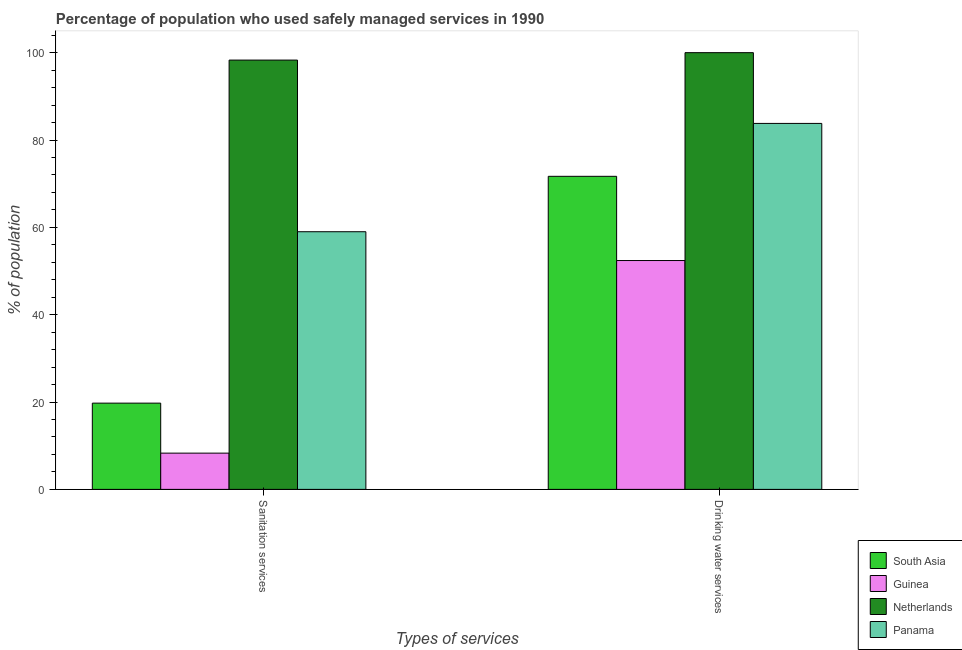How many different coloured bars are there?
Give a very brief answer. 4. How many groups of bars are there?
Your response must be concise. 2. Are the number of bars per tick equal to the number of legend labels?
Your response must be concise. Yes. Are the number of bars on each tick of the X-axis equal?
Your response must be concise. Yes. What is the label of the 2nd group of bars from the left?
Your response must be concise. Drinking water services. What is the percentage of population who used sanitation services in Netherlands?
Give a very brief answer. 98.3. Across all countries, what is the maximum percentage of population who used sanitation services?
Your answer should be compact. 98.3. Across all countries, what is the minimum percentage of population who used drinking water services?
Make the answer very short. 52.4. In which country was the percentage of population who used sanitation services maximum?
Your answer should be compact. Netherlands. In which country was the percentage of population who used sanitation services minimum?
Make the answer very short. Guinea. What is the total percentage of population who used drinking water services in the graph?
Provide a succinct answer. 307.89. What is the difference between the percentage of population who used sanitation services in South Asia and that in Guinea?
Your answer should be compact. 11.45. What is the difference between the percentage of population who used drinking water services in Guinea and the percentage of population who used sanitation services in Panama?
Your answer should be very brief. -6.6. What is the average percentage of population who used sanitation services per country?
Provide a succinct answer. 46.34. What is the difference between the percentage of population who used sanitation services and percentage of population who used drinking water services in Panama?
Provide a succinct answer. -24.8. In how many countries, is the percentage of population who used drinking water services greater than 80 %?
Offer a very short reply. 2. What is the ratio of the percentage of population who used drinking water services in Guinea to that in South Asia?
Offer a terse response. 0.73. What does the 4th bar from the left in Sanitation services represents?
Your answer should be very brief. Panama. What does the 3rd bar from the right in Drinking water services represents?
Provide a short and direct response. Guinea. Are all the bars in the graph horizontal?
Make the answer very short. No. How many countries are there in the graph?
Provide a short and direct response. 4. Are the values on the major ticks of Y-axis written in scientific E-notation?
Provide a succinct answer. No. Where does the legend appear in the graph?
Ensure brevity in your answer.  Bottom right. How are the legend labels stacked?
Your answer should be compact. Vertical. What is the title of the graph?
Offer a terse response. Percentage of population who used safely managed services in 1990. What is the label or title of the X-axis?
Provide a succinct answer. Types of services. What is the label or title of the Y-axis?
Provide a short and direct response. % of population. What is the % of population of South Asia in Sanitation services?
Your answer should be very brief. 19.75. What is the % of population in Netherlands in Sanitation services?
Provide a short and direct response. 98.3. What is the % of population of Panama in Sanitation services?
Offer a terse response. 59. What is the % of population of South Asia in Drinking water services?
Provide a succinct answer. 71.69. What is the % of population of Guinea in Drinking water services?
Give a very brief answer. 52.4. What is the % of population of Netherlands in Drinking water services?
Provide a succinct answer. 100. What is the % of population in Panama in Drinking water services?
Provide a succinct answer. 83.8. Across all Types of services, what is the maximum % of population in South Asia?
Provide a succinct answer. 71.69. Across all Types of services, what is the maximum % of population of Guinea?
Offer a very short reply. 52.4. Across all Types of services, what is the maximum % of population of Netherlands?
Offer a terse response. 100. Across all Types of services, what is the maximum % of population of Panama?
Offer a terse response. 83.8. Across all Types of services, what is the minimum % of population in South Asia?
Your answer should be very brief. 19.75. Across all Types of services, what is the minimum % of population in Netherlands?
Give a very brief answer. 98.3. What is the total % of population in South Asia in the graph?
Ensure brevity in your answer.  91.44. What is the total % of population of Guinea in the graph?
Offer a terse response. 60.7. What is the total % of population of Netherlands in the graph?
Ensure brevity in your answer.  198.3. What is the total % of population of Panama in the graph?
Provide a short and direct response. 142.8. What is the difference between the % of population of South Asia in Sanitation services and that in Drinking water services?
Make the answer very short. -51.93. What is the difference between the % of population in Guinea in Sanitation services and that in Drinking water services?
Your answer should be very brief. -44.1. What is the difference between the % of population of Panama in Sanitation services and that in Drinking water services?
Provide a short and direct response. -24.8. What is the difference between the % of population in South Asia in Sanitation services and the % of population in Guinea in Drinking water services?
Your response must be concise. -32.65. What is the difference between the % of population in South Asia in Sanitation services and the % of population in Netherlands in Drinking water services?
Your answer should be compact. -80.25. What is the difference between the % of population in South Asia in Sanitation services and the % of population in Panama in Drinking water services?
Your answer should be compact. -64.05. What is the difference between the % of population of Guinea in Sanitation services and the % of population of Netherlands in Drinking water services?
Make the answer very short. -91.7. What is the difference between the % of population of Guinea in Sanitation services and the % of population of Panama in Drinking water services?
Keep it short and to the point. -75.5. What is the average % of population of South Asia per Types of services?
Provide a succinct answer. 45.72. What is the average % of population in Guinea per Types of services?
Offer a very short reply. 30.35. What is the average % of population of Netherlands per Types of services?
Your answer should be compact. 99.15. What is the average % of population of Panama per Types of services?
Ensure brevity in your answer.  71.4. What is the difference between the % of population of South Asia and % of population of Guinea in Sanitation services?
Your answer should be compact. 11.45. What is the difference between the % of population in South Asia and % of population in Netherlands in Sanitation services?
Keep it short and to the point. -78.55. What is the difference between the % of population in South Asia and % of population in Panama in Sanitation services?
Offer a very short reply. -39.25. What is the difference between the % of population in Guinea and % of population in Netherlands in Sanitation services?
Give a very brief answer. -90. What is the difference between the % of population of Guinea and % of population of Panama in Sanitation services?
Make the answer very short. -50.7. What is the difference between the % of population of Netherlands and % of population of Panama in Sanitation services?
Make the answer very short. 39.3. What is the difference between the % of population in South Asia and % of population in Guinea in Drinking water services?
Give a very brief answer. 19.29. What is the difference between the % of population of South Asia and % of population of Netherlands in Drinking water services?
Provide a short and direct response. -28.32. What is the difference between the % of population in South Asia and % of population in Panama in Drinking water services?
Your response must be concise. -12.12. What is the difference between the % of population in Guinea and % of population in Netherlands in Drinking water services?
Your response must be concise. -47.6. What is the difference between the % of population in Guinea and % of population in Panama in Drinking water services?
Your answer should be compact. -31.4. What is the difference between the % of population in Netherlands and % of population in Panama in Drinking water services?
Provide a short and direct response. 16.2. What is the ratio of the % of population of South Asia in Sanitation services to that in Drinking water services?
Your answer should be very brief. 0.28. What is the ratio of the % of population in Guinea in Sanitation services to that in Drinking water services?
Give a very brief answer. 0.16. What is the ratio of the % of population in Netherlands in Sanitation services to that in Drinking water services?
Make the answer very short. 0.98. What is the ratio of the % of population in Panama in Sanitation services to that in Drinking water services?
Your answer should be very brief. 0.7. What is the difference between the highest and the second highest % of population of South Asia?
Keep it short and to the point. 51.93. What is the difference between the highest and the second highest % of population in Guinea?
Ensure brevity in your answer.  44.1. What is the difference between the highest and the second highest % of population in Netherlands?
Your response must be concise. 1.7. What is the difference between the highest and the second highest % of population of Panama?
Your answer should be compact. 24.8. What is the difference between the highest and the lowest % of population of South Asia?
Offer a terse response. 51.93. What is the difference between the highest and the lowest % of population of Guinea?
Ensure brevity in your answer.  44.1. What is the difference between the highest and the lowest % of population in Netherlands?
Your answer should be very brief. 1.7. What is the difference between the highest and the lowest % of population of Panama?
Keep it short and to the point. 24.8. 